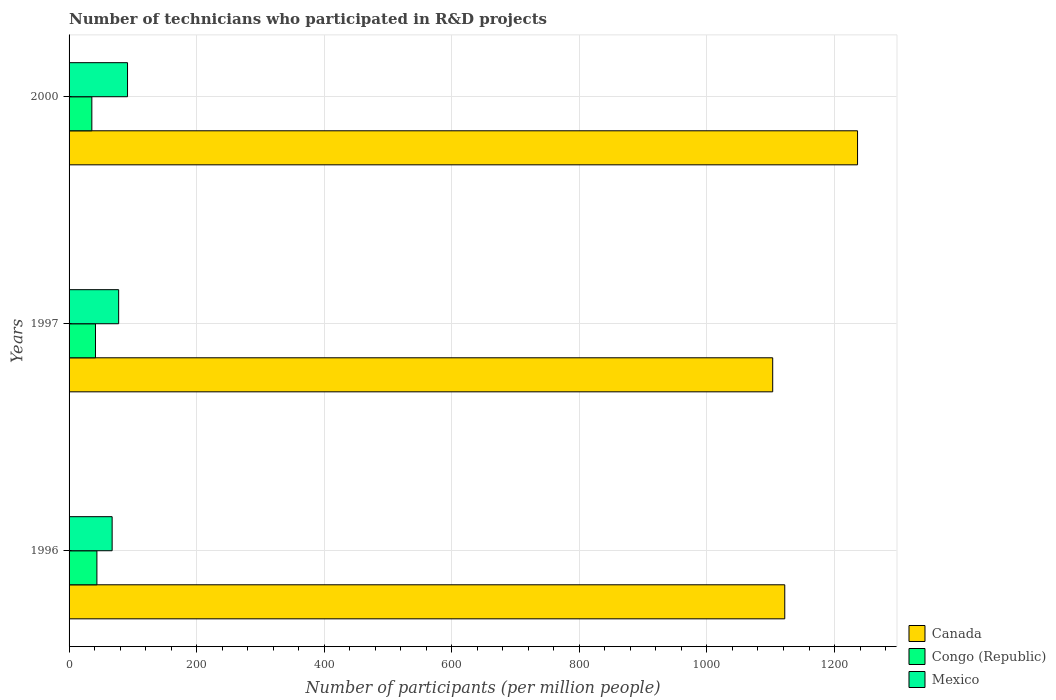Are the number of bars per tick equal to the number of legend labels?
Offer a terse response. Yes. What is the label of the 3rd group of bars from the top?
Offer a very short reply. 1996. What is the number of technicians who participated in R&D projects in Mexico in 2000?
Your answer should be compact. 91.65. Across all years, what is the maximum number of technicians who participated in R&D projects in Canada?
Provide a succinct answer. 1236.08. Across all years, what is the minimum number of technicians who participated in R&D projects in Canada?
Ensure brevity in your answer.  1103.07. In which year was the number of technicians who participated in R&D projects in Canada maximum?
Your answer should be very brief. 2000. In which year was the number of technicians who participated in R&D projects in Congo (Republic) minimum?
Offer a very short reply. 2000. What is the total number of technicians who participated in R&D projects in Congo (Republic) in the graph?
Your answer should be compact. 120.75. What is the difference between the number of technicians who participated in R&D projects in Mexico in 1996 and that in 2000?
Provide a succinct answer. -24.14. What is the difference between the number of technicians who participated in R&D projects in Canada in 1996 and the number of technicians who participated in R&D projects in Congo (Republic) in 2000?
Your answer should be very brief. 1086.26. What is the average number of technicians who participated in R&D projects in Congo (Republic) per year?
Your response must be concise. 40.25. In the year 1997, what is the difference between the number of technicians who participated in R&D projects in Canada and number of technicians who participated in R&D projects in Mexico?
Keep it short and to the point. 1025.35. What is the ratio of the number of technicians who participated in R&D projects in Canada in 1997 to that in 2000?
Provide a succinct answer. 0.89. Is the number of technicians who participated in R&D projects in Mexico in 1997 less than that in 2000?
Your response must be concise. Yes. Is the difference between the number of technicians who participated in R&D projects in Canada in 1996 and 2000 greater than the difference between the number of technicians who participated in R&D projects in Mexico in 1996 and 2000?
Offer a very short reply. No. What is the difference between the highest and the second highest number of technicians who participated in R&D projects in Congo (Republic)?
Make the answer very short. 2.22. What is the difference between the highest and the lowest number of technicians who participated in R&D projects in Canada?
Ensure brevity in your answer.  133.01. Is the sum of the number of technicians who participated in R&D projects in Mexico in 1996 and 1997 greater than the maximum number of technicians who participated in R&D projects in Congo (Republic) across all years?
Offer a very short reply. Yes. What does the 2nd bar from the top in 1997 represents?
Provide a short and direct response. Congo (Republic). What does the 1st bar from the bottom in 2000 represents?
Give a very brief answer. Canada. How many bars are there?
Your answer should be very brief. 9. Are all the bars in the graph horizontal?
Provide a succinct answer. Yes. How many years are there in the graph?
Provide a short and direct response. 3. Where does the legend appear in the graph?
Ensure brevity in your answer.  Bottom right. How are the legend labels stacked?
Offer a very short reply. Vertical. What is the title of the graph?
Provide a short and direct response. Number of technicians who participated in R&D projects. What is the label or title of the X-axis?
Offer a very short reply. Number of participants (per million people). What is the Number of participants (per million people) of Canada in 1996?
Offer a terse response. 1121.96. What is the Number of participants (per million people) of Congo (Republic) in 1996?
Your answer should be very brief. 43.64. What is the Number of participants (per million people) in Mexico in 1996?
Provide a succinct answer. 67.51. What is the Number of participants (per million people) of Canada in 1997?
Offer a very short reply. 1103.07. What is the Number of participants (per million people) of Congo (Republic) in 1997?
Offer a very short reply. 41.41. What is the Number of participants (per million people) of Mexico in 1997?
Offer a very short reply. 77.72. What is the Number of participants (per million people) of Canada in 2000?
Your answer should be very brief. 1236.08. What is the Number of participants (per million people) of Congo (Republic) in 2000?
Keep it short and to the point. 35.7. What is the Number of participants (per million people) in Mexico in 2000?
Your answer should be very brief. 91.65. Across all years, what is the maximum Number of participants (per million people) of Canada?
Give a very brief answer. 1236.08. Across all years, what is the maximum Number of participants (per million people) of Congo (Republic)?
Give a very brief answer. 43.64. Across all years, what is the maximum Number of participants (per million people) in Mexico?
Keep it short and to the point. 91.65. Across all years, what is the minimum Number of participants (per million people) in Canada?
Give a very brief answer. 1103.07. Across all years, what is the minimum Number of participants (per million people) in Congo (Republic)?
Provide a short and direct response. 35.7. Across all years, what is the minimum Number of participants (per million people) in Mexico?
Your answer should be compact. 67.51. What is the total Number of participants (per million people) of Canada in the graph?
Your answer should be compact. 3461.12. What is the total Number of participants (per million people) in Congo (Republic) in the graph?
Your answer should be very brief. 120.75. What is the total Number of participants (per million people) of Mexico in the graph?
Your answer should be very brief. 236.88. What is the difference between the Number of participants (per million people) of Canada in 1996 and that in 1997?
Offer a very short reply. 18.89. What is the difference between the Number of participants (per million people) of Congo (Republic) in 1996 and that in 1997?
Your answer should be very brief. 2.22. What is the difference between the Number of participants (per million people) of Mexico in 1996 and that in 1997?
Your answer should be compact. -10.21. What is the difference between the Number of participants (per million people) of Canada in 1996 and that in 2000?
Give a very brief answer. -114.12. What is the difference between the Number of participants (per million people) in Congo (Republic) in 1996 and that in 2000?
Make the answer very short. 7.94. What is the difference between the Number of participants (per million people) in Mexico in 1996 and that in 2000?
Make the answer very short. -24.14. What is the difference between the Number of participants (per million people) of Canada in 1997 and that in 2000?
Offer a very short reply. -133.01. What is the difference between the Number of participants (per million people) in Congo (Republic) in 1997 and that in 2000?
Keep it short and to the point. 5.71. What is the difference between the Number of participants (per million people) in Mexico in 1997 and that in 2000?
Your answer should be very brief. -13.92. What is the difference between the Number of participants (per million people) of Canada in 1996 and the Number of participants (per million people) of Congo (Republic) in 1997?
Make the answer very short. 1080.55. What is the difference between the Number of participants (per million people) in Canada in 1996 and the Number of participants (per million people) in Mexico in 1997?
Give a very brief answer. 1044.24. What is the difference between the Number of participants (per million people) of Congo (Republic) in 1996 and the Number of participants (per million people) of Mexico in 1997?
Your answer should be compact. -34.09. What is the difference between the Number of participants (per million people) in Canada in 1996 and the Number of participants (per million people) in Congo (Republic) in 2000?
Your answer should be compact. 1086.26. What is the difference between the Number of participants (per million people) in Canada in 1996 and the Number of participants (per million people) in Mexico in 2000?
Keep it short and to the point. 1030.32. What is the difference between the Number of participants (per million people) of Congo (Republic) in 1996 and the Number of participants (per million people) of Mexico in 2000?
Your answer should be compact. -48.01. What is the difference between the Number of participants (per million people) in Canada in 1997 and the Number of participants (per million people) in Congo (Republic) in 2000?
Give a very brief answer. 1067.37. What is the difference between the Number of participants (per million people) in Canada in 1997 and the Number of participants (per million people) in Mexico in 2000?
Make the answer very short. 1011.43. What is the difference between the Number of participants (per million people) in Congo (Republic) in 1997 and the Number of participants (per million people) in Mexico in 2000?
Your answer should be very brief. -50.24. What is the average Number of participants (per million people) of Canada per year?
Your answer should be very brief. 1153.71. What is the average Number of participants (per million people) of Congo (Republic) per year?
Provide a short and direct response. 40.25. What is the average Number of participants (per million people) in Mexico per year?
Make the answer very short. 78.96. In the year 1996, what is the difference between the Number of participants (per million people) of Canada and Number of participants (per million people) of Congo (Republic)?
Offer a terse response. 1078.33. In the year 1996, what is the difference between the Number of participants (per million people) in Canada and Number of participants (per million people) in Mexico?
Provide a succinct answer. 1054.46. In the year 1996, what is the difference between the Number of participants (per million people) in Congo (Republic) and Number of participants (per million people) in Mexico?
Provide a succinct answer. -23.87. In the year 1997, what is the difference between the Number of participants (per million people) in Canada and Number of participants (per million people) in Congo (Republic)?
Provide a succinct answer. 1061.66. In the year 1997, what is the difference between the Number of participants (per million people) in Canada and Number of participants (per million people) in Mexico?
Offer a terse response. 1025.35. In the year 1997, what is the difference between the Number of participants (per million people) of Congo (Republic) and Number of participants (per million people) of Mexico?
Offer a terse response. -36.31. In the year 2000, what is the difference between the Number of participants (per million people) of Canada and Number of participants (per million people) of Congo (Republic)?
Give a very brief answer. 1200.38. In the year 2000, what is the difference between the Number of participants (per million people) in Canada and Number of participants (per million people) in Mexico?
Offer a very short reply. 1144.43. In the year 2000, what is the difference between the Number of participants (per million people) of Congo (Republic) and Number of participants (per million people) of Mexico?
Ensure brevity in your answer.  -55.95. What is the ratio of the Number of participants (per million people) in Canada in 1996 to that in 1997?
Provide a short and direct response. 1.02. What is the ratio of the Number of participants (per million people) in Congo (Republic) in 1996 to that in 1997?
Keep it short and to the point. 1.05. What is the ratio of the Number of participants (per million people) in Mexico in 1996 to that in 1997?
Ensure brevity in your answer.  0.87. What is the ratio of the Number of participants (per million people) of Canada in 1996 to that in 2000?
Keep it short and to the point. 0.91. What is the ratio of the Number of participants (per million people) of Congo (Republic) in 1996 to that in 2000?
Offer a terse response. 1.22. What is the ratio of the Number of participants (per million people) in Mexico in 1996 to that in 2000?
Your answer should be very brief. 0.74. What is the ratio of the Number of participants (per million people) of Canada in 1997 to that in 2000?
Your answer should be very brief. 0.89. What is the ratio of the Number of participants (per million people) of Congo (Republic) in 1997 to that in 2000?
Ensure brevity in your answer.  1.16. What is the ratio of the Number of participants (per million people) in Mexico in 1997 to that in 2000?
Your response must be concise. 0.85. What is the difference between the highest and the second highest Number of participants (per million people) of Canada?
Offer a very short reply. 114.12. What is the difference between the highest and the second highest Number of participants (per million people) in Congo (Republic)?
Provide a short and direct response. 2.22. What is the difference between the highest and the second highest Number of participants (per million people) of Mexico?
Provide a short and direct response. 13.92. What is the difference between the highest and the lowest Number of participants (per million people) of Canada?
Provide a short and direct response. 133.01. What is the difference between the highest and the lowest Number of participants (per million people) of Congo (Republic)?
Make the answer very short. 7.94. What is the difference between the highest and the lowest Number of participants (per million people) of Mexico?
Make the answer very short. 24.14. 